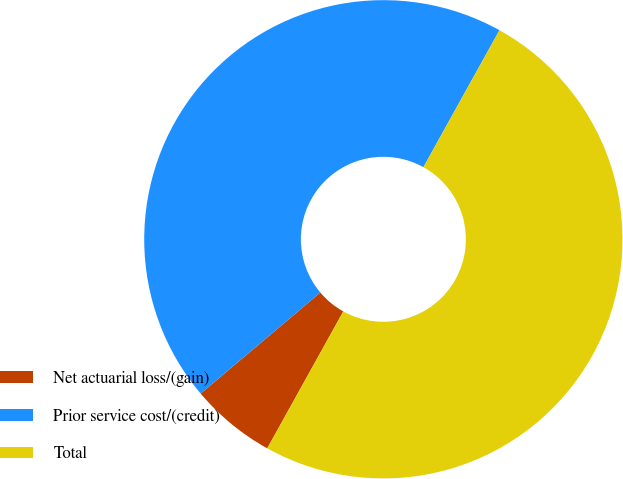Convert chart. <chart><loc_0><loc_0><loc_500><loc_500><pie_chart><fcel>Net actuarial loss/(gain)<fcel>Prior service cost/(credit)<fcel>Total<nl><fcel>5.77%<fcel>44.23%<fcel>50.0%<nl></chart> 